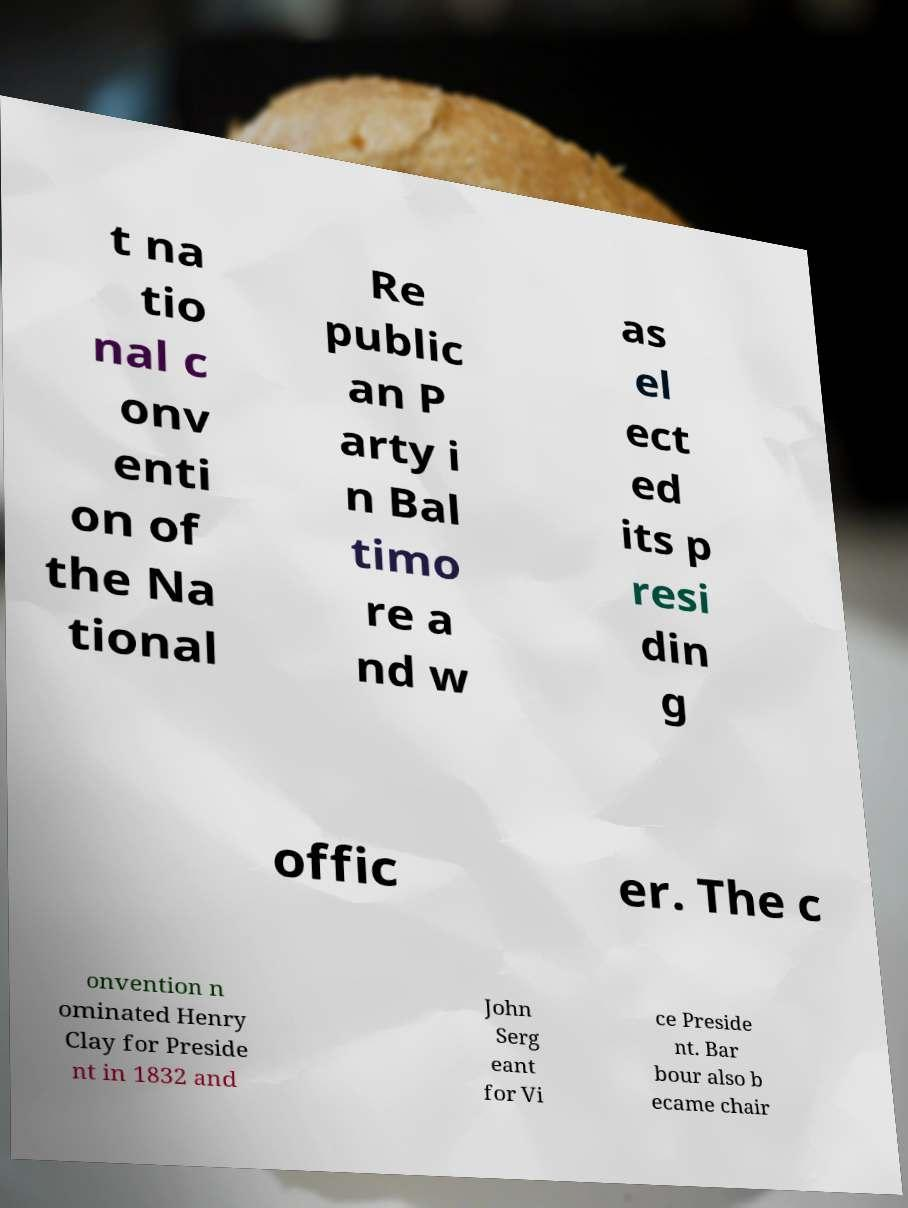For documentation purposes, I need the text within this image transcribed. Could you provide that? t na tio nal c onv enti on of the Na tional Re public an P arty i n Bal timo re a nd w as el ect ed its p resi din g offic er. The c onvention n ominated Henry Clay for Preside nt in 1832 and John Serg eant for Vi ce Preside nt. Bar bour also b ecame chair 